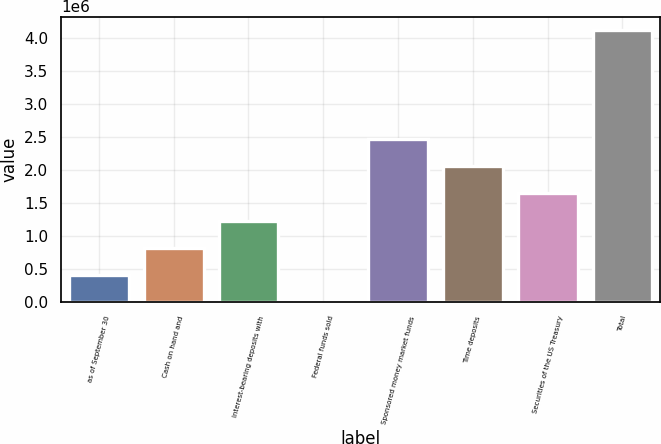<chart> <loc_0><loc_0><loc_500><loc_500><bar_chart><fcel>as of September 30<fcel>Cash on hand and<fcel>Interest-bearing deposits with<fcel>Federal funds sold<fcel>Sponsored money market funds<fcel>Time deposits<fcel>Securities of the US Treasury<fcel>Total<nl><fcel>413306<fcel>825574<fcel>1.23784e+06<fcel>1038<fcel>2.47464e+06<fcel>2.06238e+06<fcel>1.65011e+06<fcel>4.12372e+06<nl></chart> 